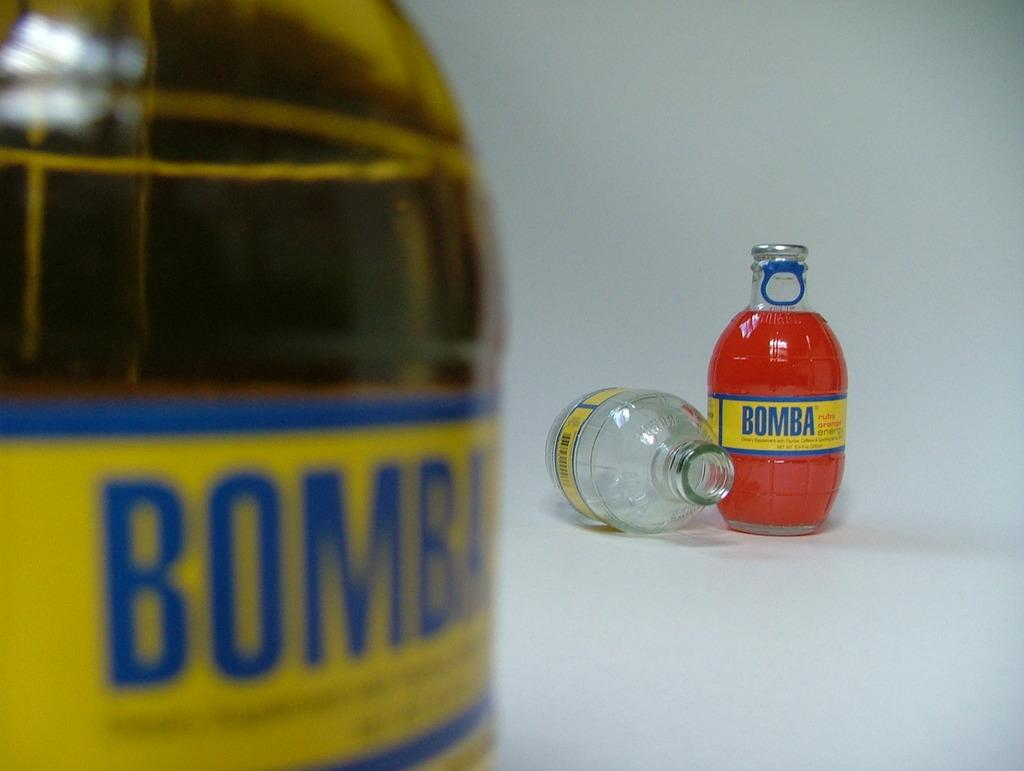<image>
Give a short and clear explanation of the subsequent image. a bottle with a yellow label that says 'bomba' onit 